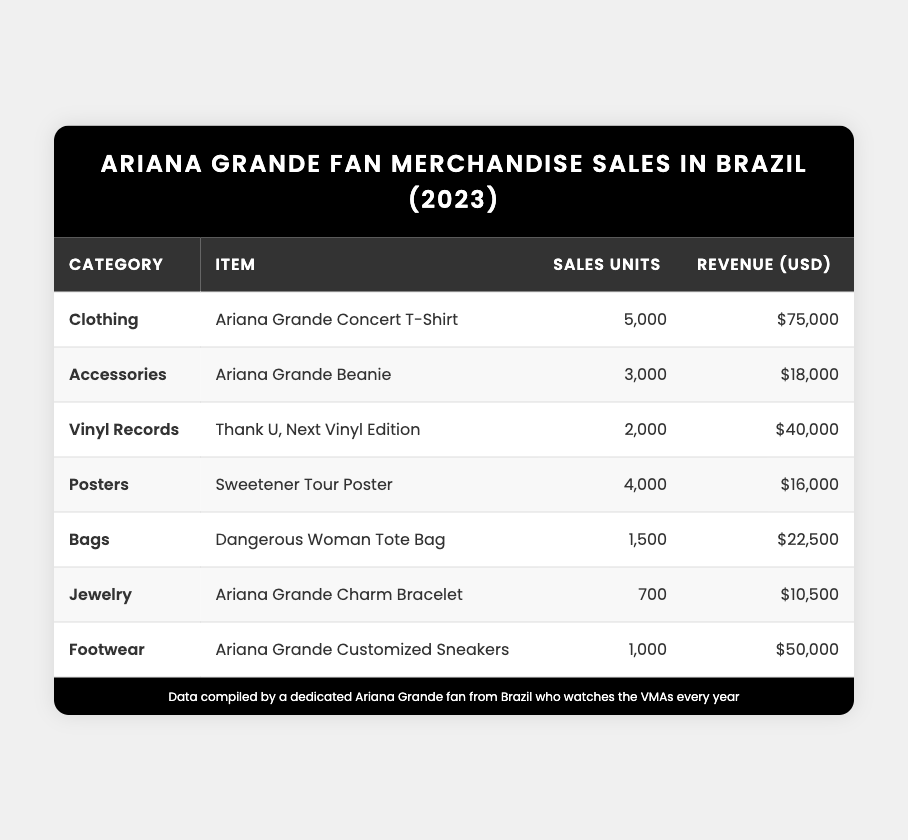What is the total revenue generated from the "Ariana Grande Concert T-Shirt"? The revenue for the "Ariana Grande Concert T-Shirt" is listed as $75,000 in the table.
Answer: $75,000 How many units of the "Ariana Grande Beanie" were sold? The table shows that 3,000 units of the "Ariana Grande Beanie" were sold.
Answer: 3,000 What was the total number of units sold for all merchandise categories combined? Adding all sales units together: 5000 + 3000 + 2000 + 4000 + 1500 + 700 + 1000 = 12,200 units sold in total.
Answer: 12,200 Which item generated the highest revenue? The "Ariana Grande Concert T-Shirt" generated the highest revenue at $75,000.
Answer: Ariana Grande Concert T-Shirt Did the "Sweetener Tour Poster" sell more units than the "Dangerous Woman Tote Bag"? Yes, the "Sweetener Tour Poster" sold 4,000 units, while the "Dangerous Woman Tote Bag" sold 1,500 units.
Answer: Yes What is the average revenue of all merchandise types listed? Sum of all revenues: $75,000 + $18,000 + $40,000 + $16,000 + $22,500 + $10,500 + $50,000 = $232,000. There are 7 items, so average revenue = $232,000 / 7 = $33,142.86.
Answer: $33,142.86 How much revenue was generated from Jewelry? The revenue generated from the "Ariana Grande Charm Bracelet" in the Jewelry category is listed as $10,500.
Answer: $10,500 Which category had the least number of sales units? The Jewelry category, with 700 units sold (Ariana Grande Charm Bracelet), had the least sales units.
Answer: Jewelry If we combine the sales of Footwear and Accessories, how many units were sold? Sales units for Footwear are 1,000 and for Accessories are 3,000. Combined: 1,000 + 3,000 = 4,000 units sold.
Answer: 4,000 Is it true that the revenue from "Thank U, Next Vinyl Edition" is more than the revenue from "Dangerous Woman Tote Bag"? Yes, "Thank U, Next Vinyl Edition" revenue is $40,000, which is greater than the "Dangerous Woman Tote Bag" revenue of $22,500.
Answer: Yes What percentage of total units sold does the "Clothing" category account for? Clothing category sales: 5,000 units. Total units: 12,200. Percentage = (5000 / 12200) * 100 = 40.98%.
Answer: 40.98% 